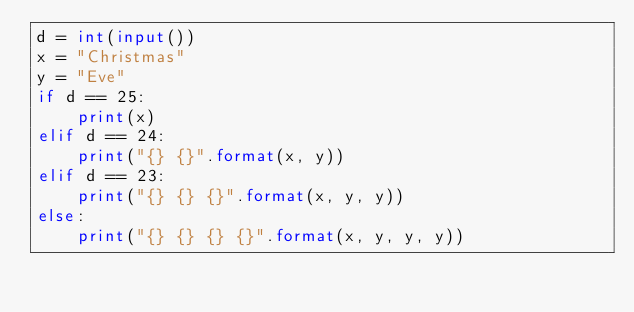<code> <loc_0><loc_0><loc_500><loc_500><_Python_>d = int(input())
x = "Christmas"
y = "Eve"
if d == 25:
    print(x)
elif d == 24:
    print("{} {}".format(x, y))
elif d == 23:
    print("{} {} {}".format(x, y, y))
else:
    print("{} {} {} {}".format(x, y, y, y))</code> 